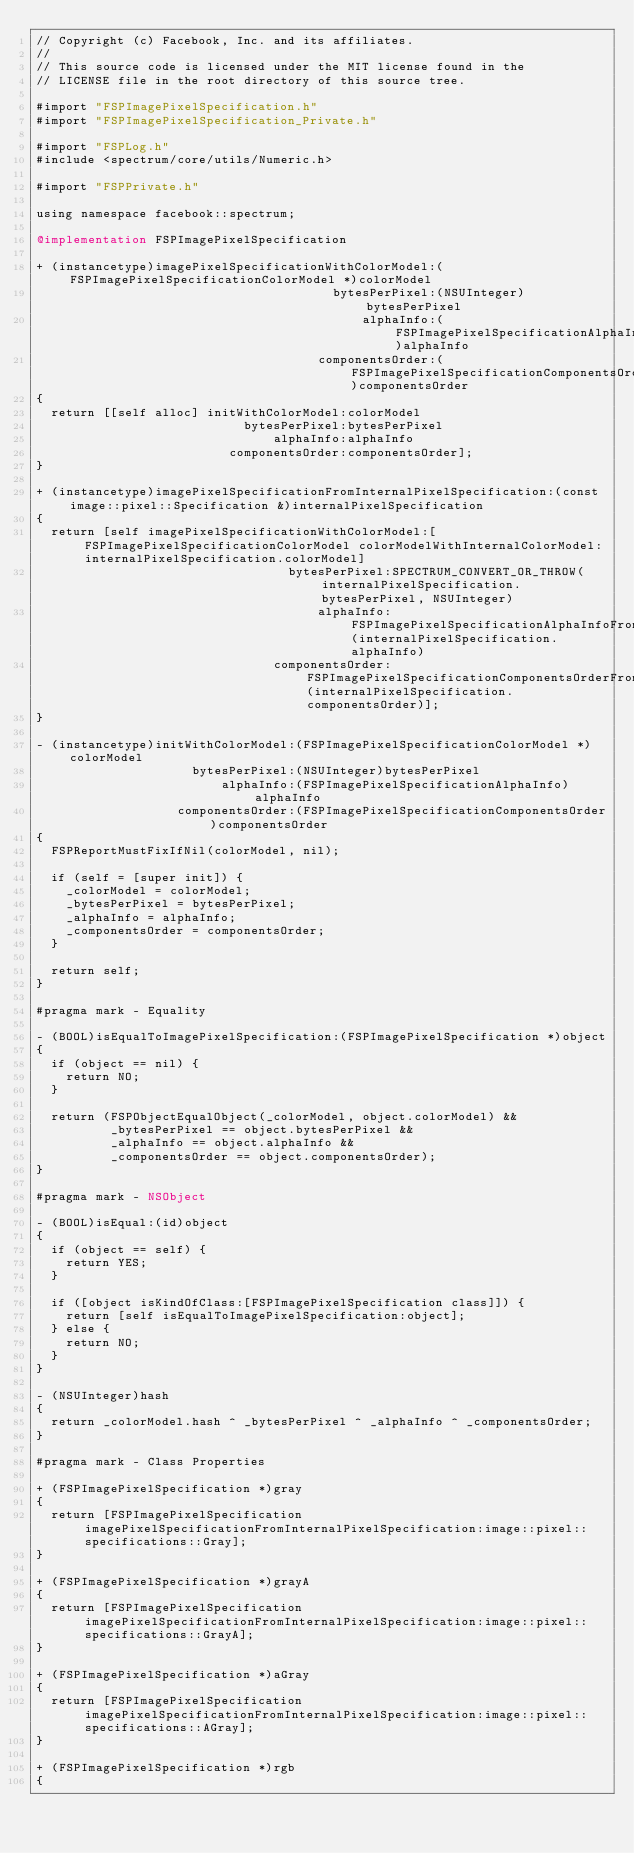<code> <loc_0><loc_0><loc_500><loc_500><_ObjectiveC_>// Copyright (c) Facebook, Inc. and its affiliates.
//
// This source code is licensed under the MIT license found in the
// LICENSE file in the root directory of this source tree.

#import "FSPImagePixelSpecification.h"
#import "FSPImagePixelSpecification_Private.h"

#import "FSPLog.h"
#include <spectrum/core/utils/Numeric.h>

#import "FSPPrivate.h"

using namespace facebook::spectrum;

@implementation FSPImagePixelSpecification

+ (instancetype)imagePixelSpecificationWithColorModel:(FSPImagePixelSpecificationColorModel *)colorModel
                                        bytesPerPixel:(NSUInteger)bytesPerPixel
                                            alphaInfo:(FSPImagePixelSpecificationAlphaInfo)alphaInfo
                                      componentsOrder:(FSPImagePixelSpecificationComponentsOrder)componentsOrder
{
  return [[self alloc] initWithColorModel:colorModel
                            bytesPerPixel:bytesPerPixel
                                alphaInfo:alphaInfo
                          componentsOrder:componentsOrder];
}

+ (instancetype)imagePixelSpecificationFromInternalPixelSpecification:(const image::pixel::Specification &)internalPixelSpecification
{
  return [self imagePixelSpecificationWithColorModel:[FSPImagePixelSpecificationColorModel colorModelWithInternalColorModel:internalPixelSpecification.colorModel]
                                  bytesPerPixel:SPECTRUM_CONVERT_OR_THROW(internalPixelSpecification.bytesPerPixel, NSUInteger)
                                      alphaInfo:FSPImagePixelSpecificationAlphaInfoFromInternalAlphaInfo(internalPixelSpecification.alphaInfo)
                                componentsOrder:FSPImagePixelSpecificationComponentsOrderFromInternalComponentsOrder(internalPixelSpecification.componentsOrder)];
}

- (instancetype)initWithColorModel:(FSPImagePixelSpecificationColorModel *)colorModel
                     bytesPerPixel:(NSUInteger)bytesPerPixel
                         alphaInfo:(FSPImagePixelSpecificationAlphaInfo)alphaInfo
                   componentsOrder:(FSPImagePixelSpecificationComponentsOrder)componentsOrder
{
  FSPReportMustFixIfNil(colorModel, nil);

  if (self = [super init]) {
    _colorModel = colorModel;
    _bytesPerPixel = bytesPerPixel;
    _alphaInfo = alphaInfo;
    _componentsOrder = componentsOrder;
  }

  return self;
}

#pragma mark - Equality

- (BOOL)isEqualToImagePixelSpecification:(FSPImagePixelSpecification *)object
{
  if (object == nil) {
    return NO;
  }

  return (FSPObjectEqualObject(_colorModel, object.colorModel) &&
          _bytesPerPixel == object.bytesPerPixel &&
          _alphaInfo == object.alphaInfo &&
          _componentsOrder == object.componentsOrder);
}

#pragma mark - NSObject

- (BOOL)isEqual:(id)object
{
  if (object == self) {
    return YES;
  }

  if ([object isKindOfClass:[FSPImagePixelSpecification class]]) {
    return [self isEqualToImagePixelSpecification:object];
  } else {
    return NO;
  }
}

- (NSUInteger)hash
{
  return _colorModel.hash ^ _bytesPerPixel ^ _alphaInfo ^ _componentsOrder;
}

#pragma mark - Class Properties

+ (FSPImagePixelSpecification *)gray
{
  return [FSPImagePixelSpecification imagePixelSpecificationFromInternalPixelSpecification:image::pixel::specifications::Gray];
}

+ (FSPImagePixelSpecification *)grayA
{
  return [FSPImagePixelSpecification imagePixelSpecificationFromInternalPixelSpecification:image::pixel::specifications::GrayA];
}

+ (FSPImagePixelSpecification *)aGray
{
  return [FSPImagePixelSpecification imagePixelSpecificationFromInternalPixelSpecification:image::pixel::specifications::AGray];
}

+ (FSPImagePixelSpecification *)rgb
{</code> 